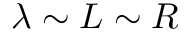Convert formula to latex. <formula><loc_0><loc_0><loc_500><loc_500>\lambda \sim L \sim R</formula> 